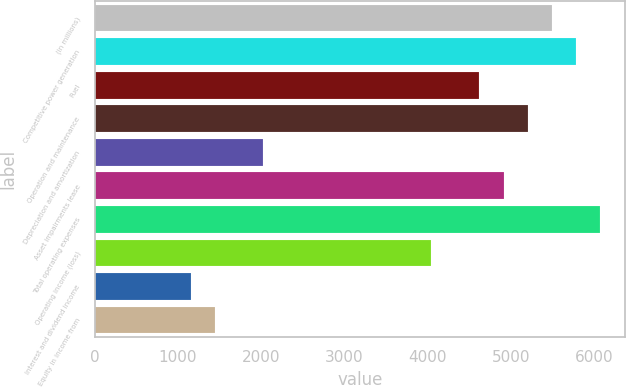Convert chart. <chart><loc_0><loc_0><loc_500><loc_500><bar_chart><fcel>(in millions)<fcel>Competitive power generation<fcel>Fuel<fcel>Operation and maintenance<fcel>Depreciation and amortization<fcel>Asset impairments lease<fcel>Total operating expenses<fcel>Operating income (loss)<fcel>Interest and dividend income<fcel>Equity in income from<nl><fcel>5488.3<fcel>5777<fcel>4622.2<fcel>5199.6<fcel>2023.9<fcel>4910.9<fcel>6065.7<fcel>4044.8<fcel>1157.8<fcel>1446.5<nl></chart> 